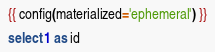Convert code to text. <code><loc_0><loc_0><loc_500><loc_500><_SQL_>{{ config(materialized='ephemeral') }}

select 1 as id
</code> 